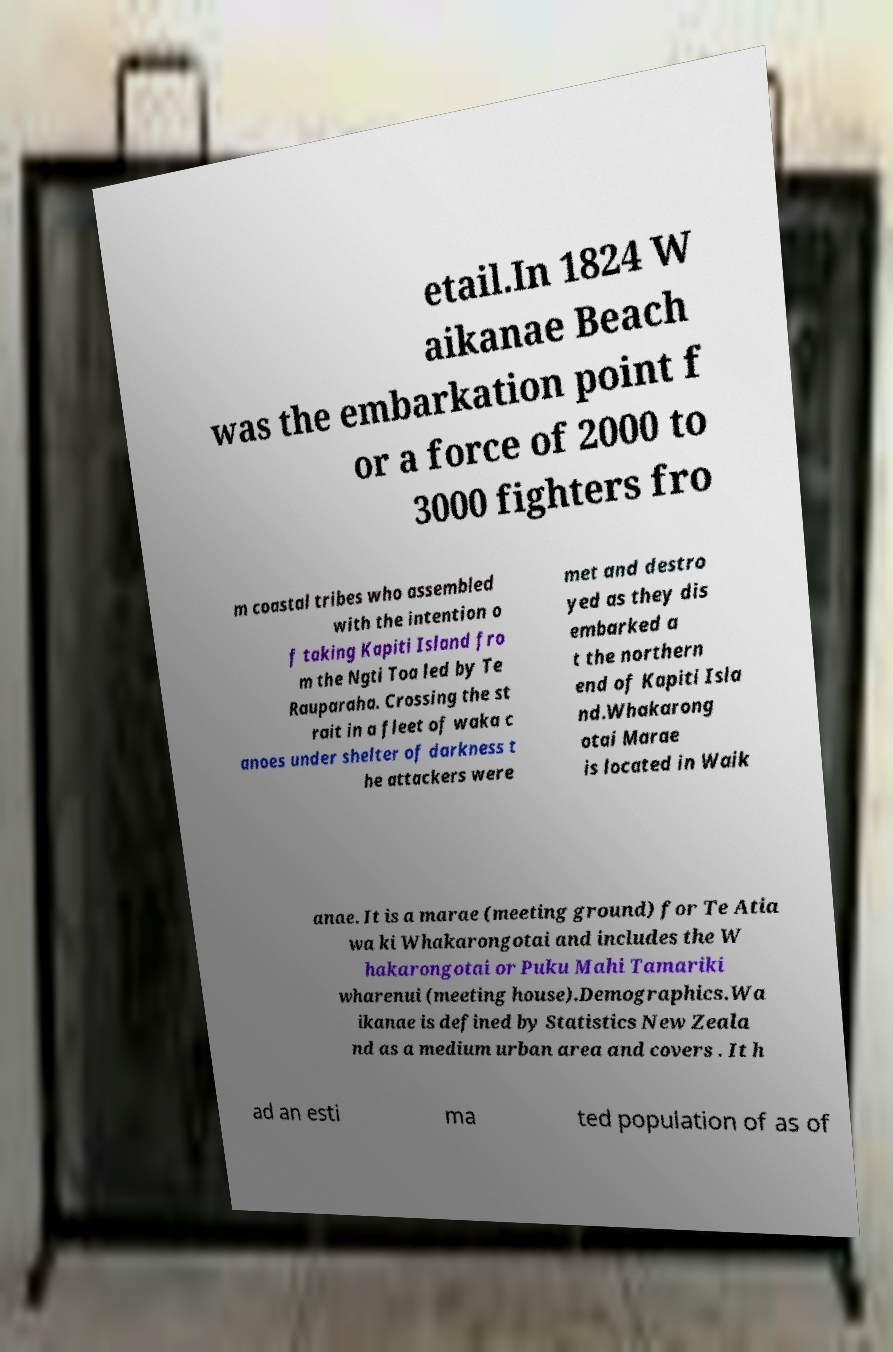What messages or text are displayed in this image? I need them in a readable, typed format. etail.In 1824 W aikanae Beach was the embarkation point f or a force of 2000 to 3000 fighters fro m coastal tribes who assembled with the intention o f taking Kapiti Island fro m the Ngti Toa led by Te Rauparaha. Crossing the st rait in a fleet of waka c anoes under shelter of darkness t he attackers were met and destro yed as they dis embarked a t the northern end of Kapiti Isla nd.Whakarong otai Marae is located in Waik anae. It is a marae (meeting ground) for Te Atia wa ki Whakarongotai and includes the W hakarongotai or Puku Mahi Tamariki wharenui (meeting house).Demographics.Wa ikanae is defined by Statistics New Zeala nd as a medium urban area and covers . It h ad an esti ma ted population of as of 